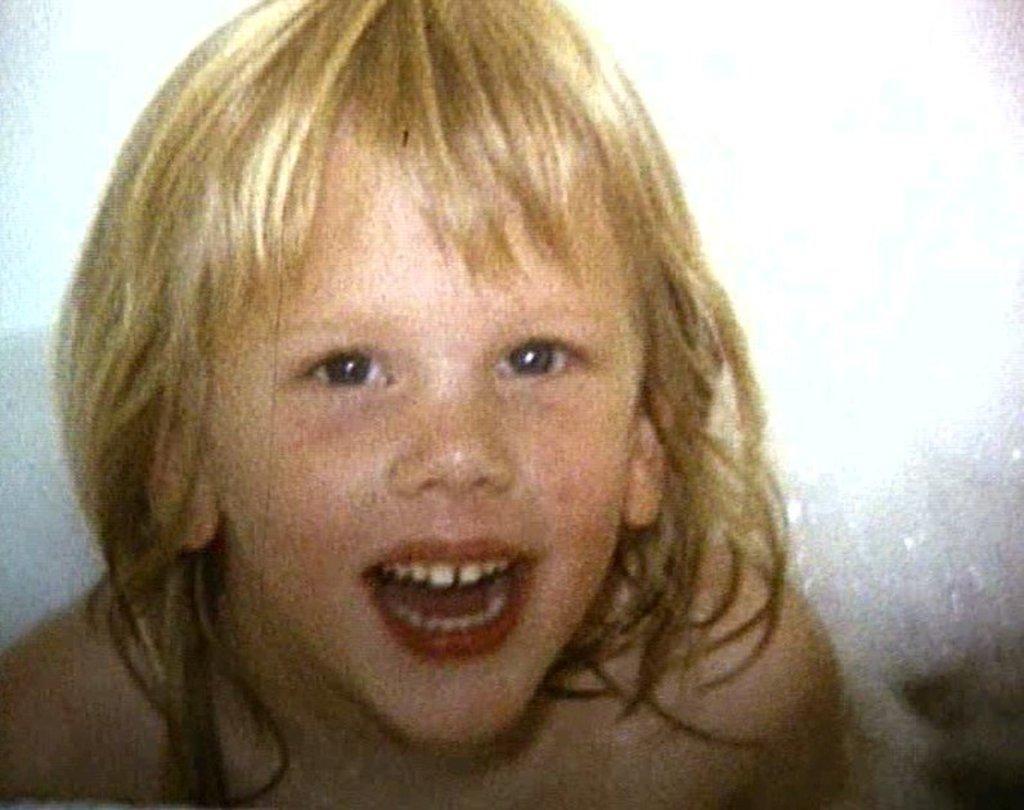Could you give a brief overview of what you see in this image? In the image in the center, we can see one kid smiling. 